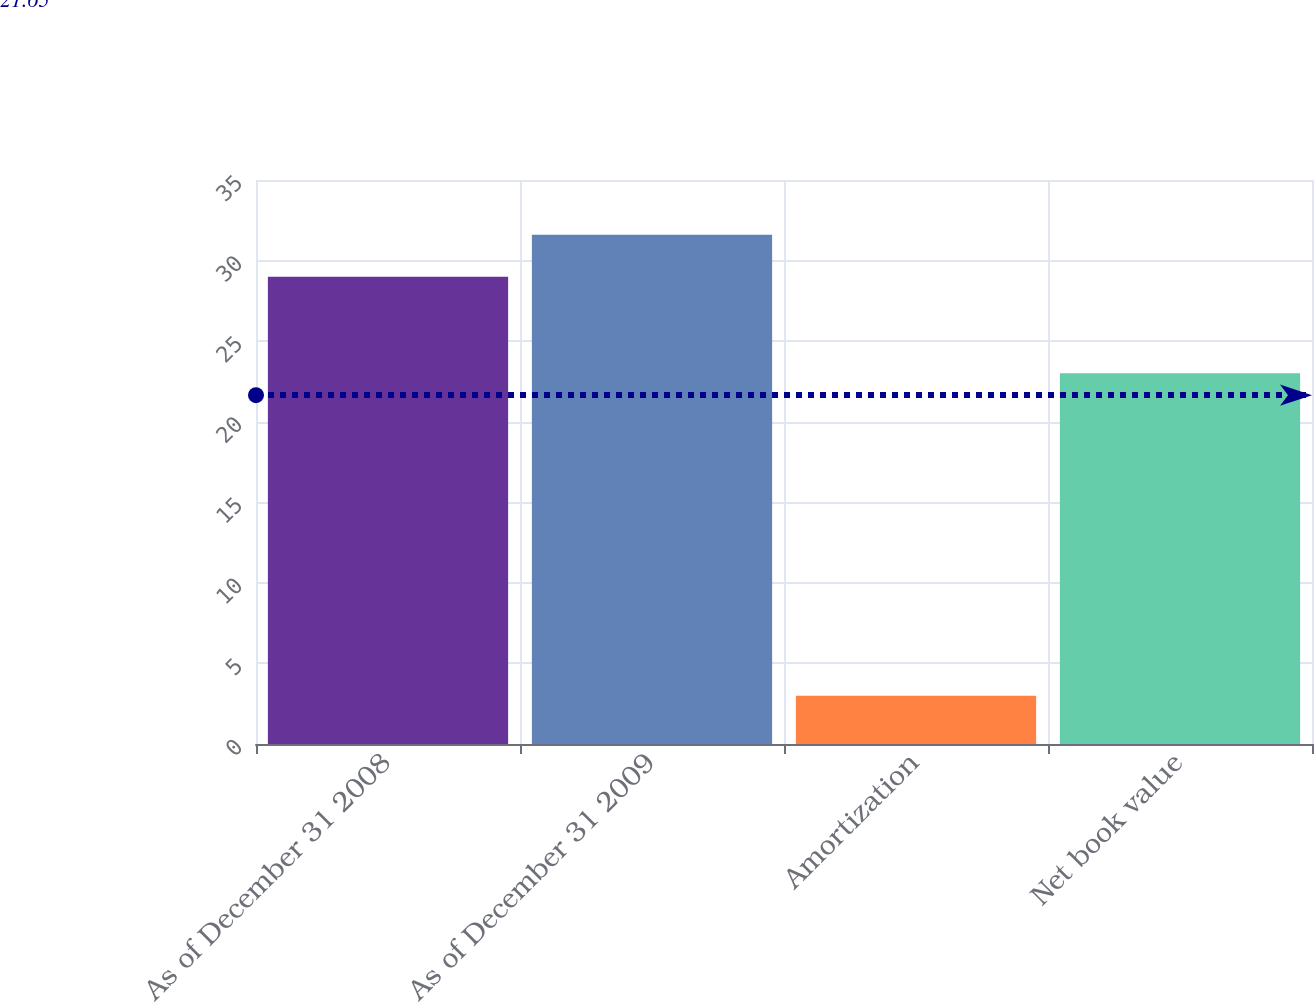Convert chart. <chart><loc_0><loc_0><loc_500><loc_500><bar_chart><fcel>As of December 31 2008<fcel>As of December 31 2009<fcel>Amortization<fcel>Net book value<nl><fcel>29<fcel>31.6<fcel>3<fcel>23<nl></chart> 